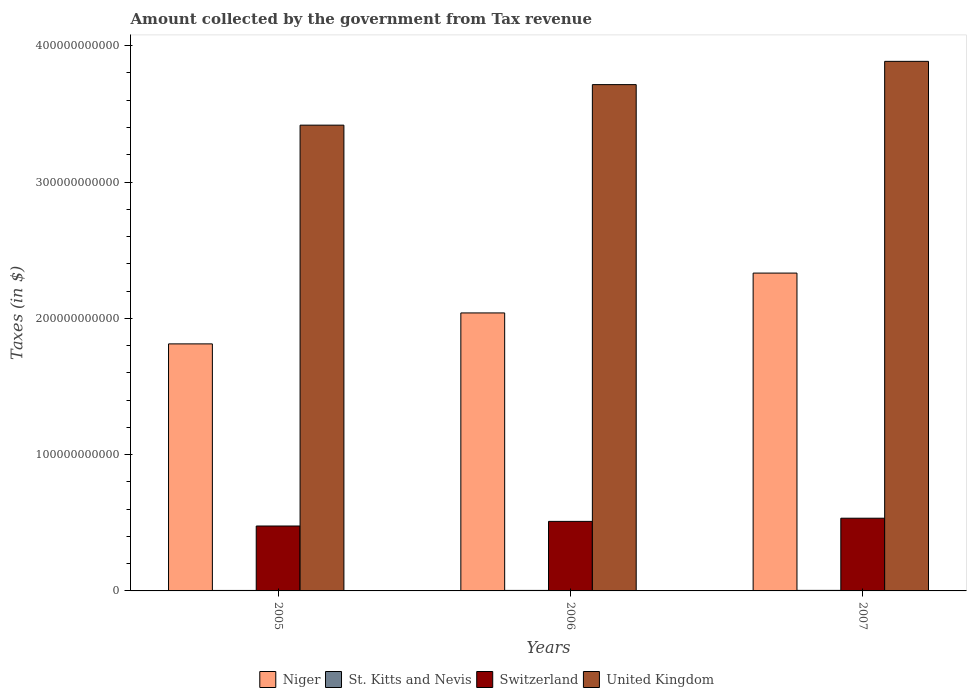How many groups of bars are there?
Provide a succinct answer. 3. Are the number of bars per tick equal to the number of legend labels?
Your answer should be very brief. Yes. How many bars are there on the 2nd tick from the right?
Provide a succinct answer. 4. What is the label of the 1st group of bars from the left?
Offer a very short reply. 2005. What is the amount collected by the government from tax revenue in Switzerland in 2007?
Give a very brief answer. 5.34e+1. Across all years, what is the maximum amount collected by the government from tax revenue in St. Kitts and Nevis?
Your response must be concise. 4.00e+08. Across all years, what is the minimum amount collected by the government from tax revenue in St. Kitts and Nevis?
Ensure brevity in your answer.  3.44e+08. In which year was the amount collected by the government from tax revenue in United Kingdom maximum?
Provide a short and direct response. 2007. In which year was the amount collected by the government from tax revenue in Niger minimum?
Make the answer very short. 2005. What is the total amount collected by the government from tax revenue in Niger in the graph?
Ensure brevity in your answer.  6.18e+11. What is the difference between the amount collected by the government from tax revenue in Switzerland in 2005 and that in 2007?
Give a very brief answer. -5.73e+09. What is the difference between the amount collected by the government from tax revenue in United Kingdom in 2007 and the amount collected by the government from tax revenue in Niger in 2005?
Your answer should be very brief. 2.07e+11. What is the average amount collected by the government from tax revenue in Niger per year?
Your answer should be compact. 2.06e+11. In the year 2006, what is the difference between the amount collected by the government from tax revenue in Niger and amount collected by the government from tax revenue in Switzerland?
Ensure brevity in your answer.  1.53e+11. In how many years, is the amount collected by the government from tax revenue in Niger greater than 360000000000 $?
Ensure brevity in your answer.  0. What is the ratio of the amount collected by the government from tax revenue in United Kingdom in 2005 to that in 2006?
Offer a terse response. 0.92. Is the amount collected by the government from tax revenue in United Kingdom in 2006 less than that in 2007?
Make the answer very short. Yes. Is the difference between the amount collected by the government from tax revenue in Niger in 2005 and 2007 greater than the difference between the amount collected by the government from tax revenue in Switzerland in 2005 and 2007?
Make the answer very short. No. What is the difference between the highest and the second highest amount collected by the government from tax revenue in St. Kitts and Nevis?
Ensure brevity in your answer.  2.55e+07. What is the difference between the highest and the lowest amount collected by the government from tax revenue in Niger?
Provide a succinct answer. 5.19e+1. Is the sum of the amount collected by the government from tax revenue in United Kingdom in 2005 and 2006 greater than the maximum amount collected by the government from tax revenue in Switzerland across all years?
Give a very brief answer. Yes. What does the 3rd bar from the left in 2006 represents?
Your answer should be compact. Switzerland. How many bars are there?
Provide a succinct answer. 12. What is the difference between two consecutive major ticks on the Y-axis?
Offer a terse response. 1.00e+11. Are the values on the major ticks of Y-axis written in scientific E-notation?
Keep it short and to the point. No. Does the graph contain grids?
Offer a terse response. No. Where does the legend appear in the graph?
Keep it short and to the point. Bottom center. How many legend labels are there?
Ensure brevity in your answer.  4. What is the title of the graph?
Your answer should be compact. Amount collected by the government from Tax revenue. What is the label or title of the Y-axis?
Provide a short and direct response. Taxes (in $). What is the Taxes (in $) of Niger in 2005?
Provide a short and direct response. 1.81e+11. What is the Taxes (in $) of St. Kitts and Nevis in 2005?
Your response must be concise. 3.44e+08. What is the Taxes (in $) of Switzerland in 2005?
Offer a very short reply. 4.76e+1. What is the Taxes (in $) of United Kingdom in 2005?
Give a very brief answer. 3.42e+11. What is the Taxes (in $) of Niger in 2006?
Ensure brevity in your answer.  2.04e+11. What is the Taxes (in $) in St. Kitts and Nevis in 2006?
Keep it short and to the point. 3.74e+08. What is the Taxes (in $) of Switzerland in 2006?
Ensure brevity in your answer.  5.10e+1. What is the Taxes (in $) in United Kingdom in 2006?
Your response must be concise. 3.71e+11. What is the Taxes (in $) in Niger in 2007?
Make the answer very short. 2.33e+11. What is the Taxes (in $) in St. Kitts and Nevis in 2007?
Provide a succinct answer. 4.00e+08. What is the Taxes (in $) of Switzerland in 2007?
Your answer should be very brief. 5.34e+1. What is the Taxes (in $) in United Kingdom in 2007?
Offer a very short reply. 3.89e+11. Across all years, what is the maximum Taxes (in $) in Niger?
Your response must be concise. 2.33e+11. Across all years, what is the maximum Taxes (in $) of St. Kitts and Nevis?
Your answer should be compact. 4.00e+08. Across all years, what is the maximum Taxes (in $) in Switzerland?
Make the answer very short. 5.34e+1. Across all years, what is the maximum Taxes (in $) of United Kingdom?
Offer a terse response. 3.89e+11. Across all years, what is the minimum Taxes (in $) of Niger?
Give a very brief answer. 1.81e+11. Across all years, what is the minimum Taxes (in $) of St. Kitts and Nevis?
Your response must be concise. 3.44e+08. Across all years, what is the minimum Taxes (in $) of Switzerland?
Provide a succinct answer. 4.76e+1. Across all years, what is the minimum Taxes (in $) of United Kingdom?
Keep it short and to the point. 3.42e+11. What is the total Taxes (in $) of Niger in the graph?
Ensure brevity in your answer.  6.18e+11. What is the total Taxes (in $) of St. Kitts and Nevis in the graph?
Your answer should be compact. 1.12e+09. What is the total Taxes (in $) in Switzerland in the graph?
Your answer should be very brief. 1.52e+11. What is the total Taxes (in $) in United Kingdom in the graph?
Provide a short and direct response. 1.10e+12. What is the difference between the Taxes (in $) of Niger in 2005 and that in 2006?
Provide a short and direct response. -2.27e+1. What is the difference between the Taxes (in $) in St. Kitts and Nevis in 2005 and that in 2006?
Provide a short and direct response. -3.00e+07. What is the difference between the Taxes (in $) in Switzerland in 2005 and that in 2006?
Ensure brevity in your answer.  -3.39e+09. What is the difference between the Taxes (in $) of United Kingdom in 2005 and that in 2006?
Ensure brevity in your answer.  -2.97e+1. What is the difference between the Taxes (in $) of Niger in 2005 and that in 2007?
Your answer should be very brief. -5.19e+1. What is the difference between the Taxes (in $) in St. Kitts and Nevis in 2005 and that in 2007?
Give a very brief answer. -5.55e+07. What is the difference between the Taxes (in $) in Switzerland in 2005 and that in 2007?
Give a very brief answer. -5.73e+09. What is the difference between the Taxes (in $) in United Kingdom in 2005 and that in 2007?
Make the answer very short. -4.68e+1. What is the difference between the Taxes (in $) of Niger in 2006 and that in 2007?
Give a very brief answer. -2.92e+1. What is the difference between the Taxes (in $) in St. Kitts and Nevis in 2006 and that in 2007?
Provide a succinct answer. -2.55e+07. What is the difference between the Taxes (in $) of Switzerland in 2006 and that in 2007?
Offer a terse response. -2.34e+09. What is the difference between the Taxes (in $) of United Kingdom in 2006 and that in 2007?
Offer a very short reply. -1.71e+1. What is the difference between the Taxes (in $) in Niger in 2005 and the Taxes (in $) in St. Kitts and Nevis in 2006?
Ensure brevity in your answer.  1.81e+11. What is the difference between the Taxes (in $) of Niger in 2005 and the Taxes (in $) of Switzerland in 2006?
Your answer should be very brief. 1.30e+11. What is the difference between the Taxes (in $) in Niger in 2005 and the Taxes (in $) in United Kingdom in 2006?
Ensure brevity in your answer.  -1.90e+11. What is the difference between the Taxes (in $) of St. Kitts and Nevis in 2005 and the Taxes (in $) of Switzerland in 2006?
Make the answer very short. -5.07e+1. What is the difference between the Taxes (in $) of St. Kitts and Nevis in 2005 and the Taxes (in $) of United Kingdom in 2006?
Give a very brief answer. -3.71e+11. What is the difference between the Taxes (in $) of Switzerland in 2005 and the Taxes (in $) of United Kingdom in 2006?
Keep it short and to the point. -3.24e+11. What is the difference between the Taxes (in $) of Niger in 2005 and the Taxes (in $) of St. Kitts and Nevis in 2007?
Offer a very short reply. 1.81e+11. What is the difference between the Taxes (in $) in Niger in 2005 and the Taxes (in $) in Switzerland in 2007?
Ensure brevity in your answer.  1.28e+11. What is the difference between the Taxes (in $) in Niger in 2005 and the Taxes (in $) in United Kingdom in 2007?
Make the answer very short. -2.07e+11. What is the difference between the Taxes (in $) in St. Kitts and Nevis in 2005 and the Taxes (in $) in Switzerland in 2007?
Make the answer very short. -5.30e+1. What is the difference between the Taxes (in $) in St. Kitts and Nevis in 2005 and the Taxes (in $) in United Kingdom in 2007?
Keep it short and to the point. -3.88e+11. What is the difference between the Taxes (in $) in Switzerland in 2005 and the Taxes (in $) in United Kingdom in 2007?
Provide a short and direct response. -3.41e+11. What is the difference between the Taxes (in $) in Niger in 2006 and the Taxes (in $) in St. Kitts and Nevis in 2007?
Your answer should be very brief. 2.04e+11. What is the difference between the Taxes (in $) of Niger in 2006 and the Taxes (in $) of Switzerland in 2007?
Provide a succinct answer. 1.51e+11. What is the difference between the Taxes (in $) in Niger in 2006 and the Taxes (in $) in United Kingdom in 2007?
Your answer should be compact. -1.85e+11. What is the difference between the Taxes (in $) of St. Kitts and Nevis in 2006 and the Taxes (in $) of Switzerland in 2007?
Your answer should be compact. -5.30e+1. What is the difference between the Taxes (in $) of St. Kitts and Nevis in 2006 and the Taxes (in $) of United Kingdom in 2007?
Keep it short and to the point. -3.88e+11. What is the difference between the Taxes (in $) in Switzerland in 2006 and the Taxes (in $) in United Kingdom in 2007?
Offer a terse response. -3.38e+11. What is the average Taxes (in $) in Niger per year?
Offer a very short reply. 2.06e+11. What is the average Taxes (in $) in St. Kitts and Nevis per year?
Provide a short and direct response. 3.73e+08. What is the average Taxes (in $) in Switzerland per year?
Offer a very short reply. 5.07e+1. What is the average Taxes (in $) of United Kingdom per year?
Offer a very short reply. 3.67e+11. In the year 2005, what is the difference between the Taxes (in $) in Niger and Taxes (in $) in St. Kitts and Nevis?
Keep it short and to the point. 1.81e+11. In the year 2005, what is the difference between the Taxes (in $) in Niger and Taxes (in $) in Switzerland?
Keep it short and to the point. 1.34e+11. In the year 2005, what is the difference between the Taxes (in $) in Niger and Taxes (in $) in United Kingdom?
Give a very brief answer. -1.60e+11. In the year 2005, what is the difference between the Taxes (in $) of St. Kitts and Nevis and Taxes (in $) of Switzerland?
Your answer should be compact. -4.73e+1. In the year 2005, what is the difference between the Taxes (in $) of St. Kitts and Nevis and Taxes (in $) of United Kingdom?
Keep it short and to the point. -3.41e+11. In the year 2005, what is the difference between the Taxes (in $) of Switzerland and Taxes (in $) of United Kingdom?
Give a very brief answer. -2.94e+11. In the year 2006, what is the difference between the Taxes (in $) of Niger and Taxes (in $) of St. Kitts and Nevis?
Ensure brevity in your answer.  2.04e+11. In the year 2006, what is the difference between the Taxes (in $) in Niger and Taxes (in $) in Switzerland?
Offer a very short reply. 1.53e+11. In the year 2006, what is the difference between the Taxes (in $) in Niger and Taxes (in $) in United Kingdom?
Provide a succinct answer. -1.68e+11. In the year 2006, what is the difference between the Taxes (in $) in St. Kitts and Nevis and Taxes (in $) in Switzerland?
Ensure brevity in your answer.  -5.06e+1. In the year 2006, what is the difference between the Taxes (in $) in St. Kitts and Nevis and Taxes (in $) in United Kingdom?
Provide a short and direct response. -3.71e+11. In the year 2006, what is the difference between the Taxes (in $) in Switzerland and Taxes (in $) in United Kingdom?
Offer a terse response. -3.20e+11. In the year 2007, what is the difference between the Taxes (in $) of Niger and Taxes (in $) of St. Kitts and Nevis?
Keep it short and to the point. 2.33e+11. In the year 2007, what is the difference between the Taxes (in $) of Niger and Taxes (in $) of Switzerland?
Give a very brief answer. 1.80e+11. In the year 2007, what is the difference between the Taxes (in $) of Niger and Taxes (in $) of United Kingdom?
Provide a succinct answer. -1.55e+11. In the year 2007, what is the difference between the Taxes (in $) of St. Kitts and Nevis and Taxes (in $) of Switzerland?
Provide a succinct answer. -5.30e+1. In the year 2007, what is the difference between the Taxes (in $) in St. Kitts and Nevis and Taxes (in $) in United Kingdom?
Ensure brevity in your answer.  -3.88e+11. In the year 2007, what is the difference between the Taxes (in $) of Switzerland and Taxes (in $) of United Kingdom?
Ensure brevity in your answer.  -3.35e+11. What is the ratio of the Taxes (in $) in Niger in 2005 to that in 2006?
Keep it short and to the point. 0.89. What is the ratio of the Taxes (in $) in St. Kitts and Nevis in 2005 to that in 2006?
Give a very brief answer. 0.92. What is the ratio of the Taxes (in $) of Switzerland in 2005 to that in 2006?
Keep it short and to the point. 0.93. What is the ratio of the Taxes (in $) of United Kingdom in 2005 to that in 2006?
Offer a very short reply. 0.92. What is the ratio of the Taxes (in $) of Niger in 2005 to that in 2007?
Offer a terse response. 0.78. What is the ratio of the Taxes (in $) of St. Kitts and Nevis in 2005 to that in 2007?
Provide a short and direct response. 0.86. What is the ratio of the Taxes (in $) in Switzerland in 2005 to that in 2007?
Your response must be concise. 0.89. What is the ratio of the Taxes (in $) in United Kingdom in 2005 to that in 2007?
Provide a short and direct response. 0.88. What is the ratio of the Taxes (in $) in Niger in 2006 to that in 2007?
Make the answer very short. 0.87. What is the ratio of the Taxes (in $) in St. Kitts and Nevis in 2006 to that in 2007?
Offer a very short reply. 0.94. What is the ratio of the Taxes (in $) in Switzerland in 2006 to that in 2007?
Your answer should be very brief. 0.96. What is the ratio of the Taxes (in $) of United Kingdom in 2006 to that in 2007?
Your response must be concise. 0.96. What is the difference between the highest and the second highest Taxes (in $) in Niger?
Your response must be concise. 2.92e+1. What is the difference between the highest and the second highest Taxes (in $) in St. Kitts and Nevis?
Your response must be concise. 2.55e+07. What is the difference between the highest and the second highest Taxes (in $) of Switzerland?
Provide a succinct answer. 2.34e+09. What is the difference between the highest and the second highest Taxes (in $) of United Kingdom?
Your answer should be very brief. 1.71e+1. What is the difference between the highest and the lowest Taxes (in $) of Niger?
Offer a terse response. 5.19e+1. What is the difference between the highest and the lowest Taxes (in $) of St. Kitts and Nevis?
Offer a very short reply. 5.55e+07. What is the difference between the highest and the lowest Taxes (in $) of Switzerland?
Keep it short and to the point. 5.73e+09. What is the difference between the highest and the lowest Taxes (in $) of United Kingdom?
Your answer should be very brief. 4.68e+1. 